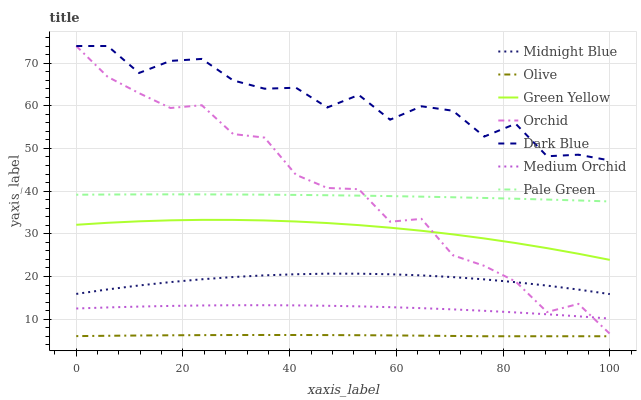Does Olive have the minimum area under the curve?
Answer yes or no. Yes. Does Dark Blue have the maximum area under the curve?
Answer yes or no. Yes. Does Medium Orchid have the minimum area under the curve?
Answer yes or no. No. Does Medium Orchid have the maximum area under the curve?
Answer yes or no. No. Is Olive the smoothest?
Answer yes or no. Yes. Is Dark Blue the roughest?
Answer yes or no. Yes. Is Medium Orchid the smoothest?
Answer yes or no. No. Is Medium Orchid the roughest?
Answer yes or no. No. Does Olive have the lowest value?
Answer yes or no. Yes. Does Medium Orchid have the lowest value?
Answer yes or no. No. Does Orchid have the highest value?
Answer yes or no. Yes. Does Medium Orchid have the highest value?
Answer yes or no. No. Is Olive less than Pale Green?
Answer yes or no. Yes. Is Dark Blue greater than Medium Orchid?
Answer yes or no. Yes. Does Midnight Blue intersect Orchid?
Answer yes or no. Yes. Is Midnight Blue less than Orchid?
Answer yes or no. No. Is Midnight Blue greater than Orchid?
Answer yes or no. No. Does Olive intersect Pale Green?
Answer yes or no. No. 